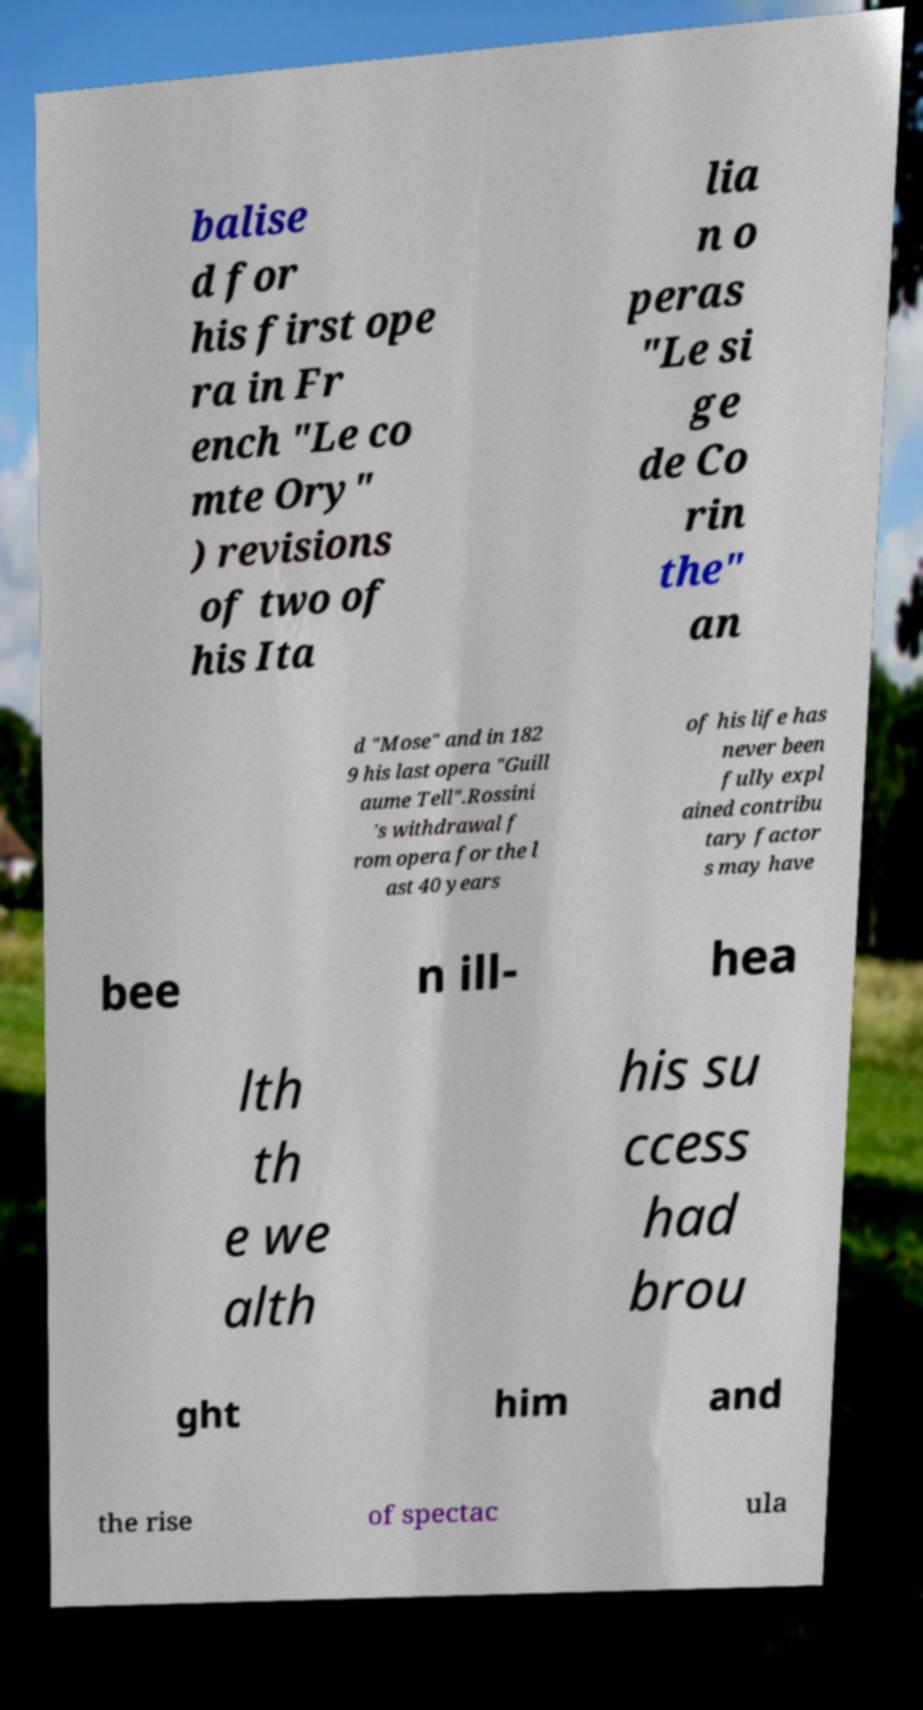Please read and relay the text visible in this image. What does it say? balise d for his first ope ra in Fr ench "Le co mte Ory" ) revisions of two of his Ita lia n o peras "Le si ge de Co rin the" an d "Mose" and in 182 9 his last opera "Guill aume Tell".Rossini 's withdrawal f rom opera for the l ast 40 years of his life has never been fully expl ained contribu tary factor s may have bee n ill- hea lth th e we alth his su ccess had brou ght him and the rise of spectac ula 